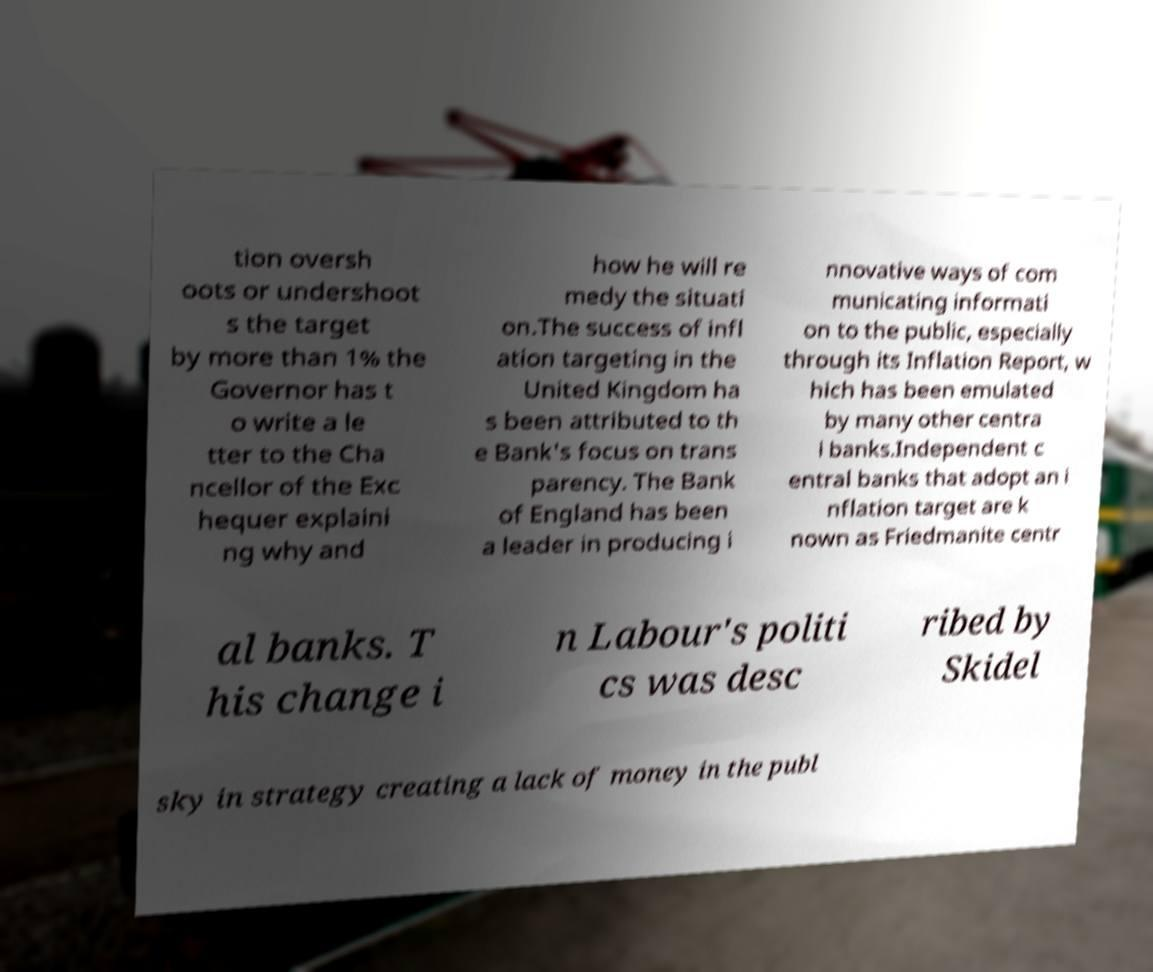Please read and relay the text visible in this image. What does it say? tion oversh oots or undershoot s the target by more than 1% the Governor has t o write a le tter to the Cha ncellor of the Exc hequer explaini ng why and how he will re medy the situati on.The success of infl ation targeting in the United Kingdom ha s been attributed to th e Bank's focus on trans parency. The Bank of England has been a leader in producing i nnovative ways of com municating informati on to the public, especially through its Inflation Report, w hich has been emulated by many other centra l banks.Independent c entral banks that adopt an i nflation target are k nown as Friedmanite centr al banks. T his change i n Labour's politi cs was desc ribed by Skidel sky in strategy creating a lack of money in the publ 